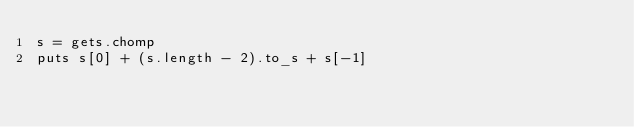Convert code to text. <code><loc_0><loc_0><loc_500><loc_500><_Ruby_>s = gets.chomp
puts s[0] + (s.length - 2).to_s + s[-1]</code> 